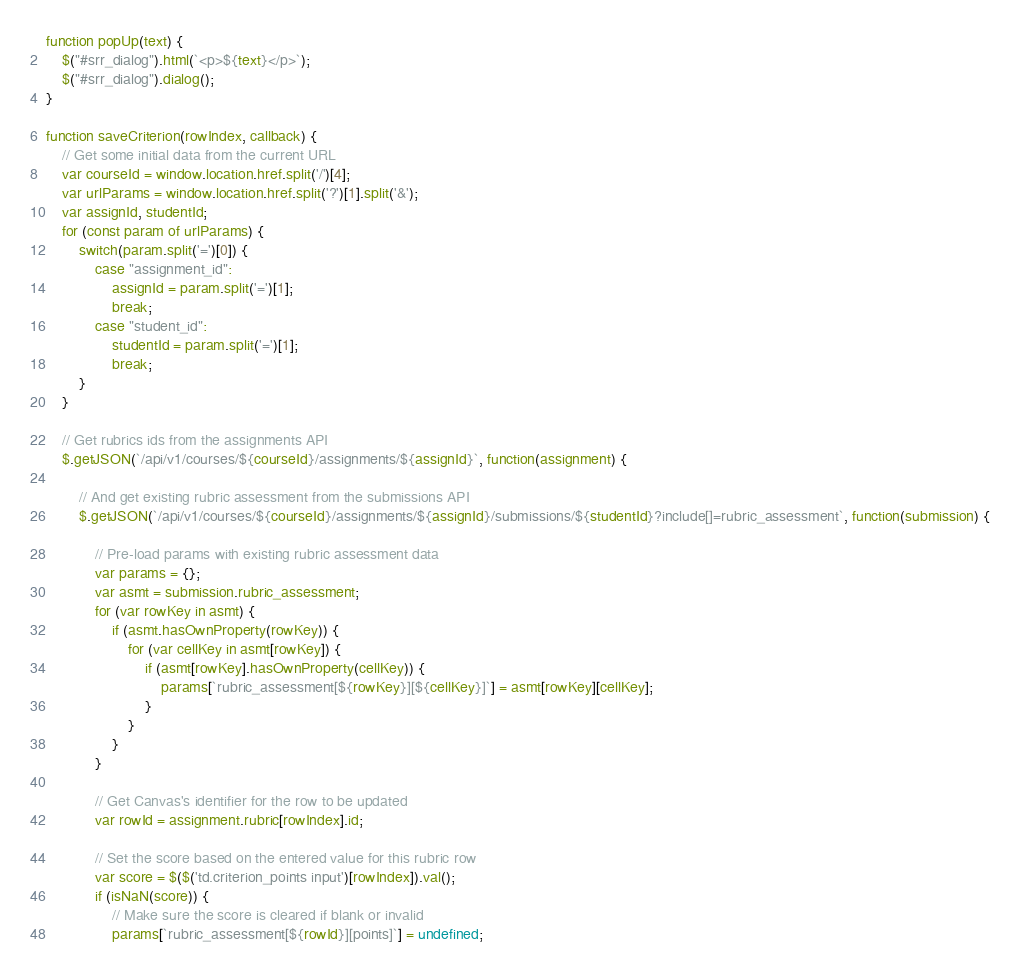<code> <loc_0><loc_0><loc_500><loc_500><_JavaScript_>function popUp(text) {
    $("#srr_dialog").html(`<p>${text}</p>`);
    $("#srr_dialog").dialog();
}

function saveCriterion(rowIndex, callback) {
    // Get some initial data from the current URL
    var courseId = window.location.href.split('/')[4];
    var urlParams = window.location.href.split('?')[1].split('&');
    var assignId, studentId;
    for (const param of urlParams) {
        switch(param.split('=')[0]) {
            case "assignment_id":
                assignId = param.split('=')[1];
                break;
            case "student_id":
                studentId = param.split('=')[1];
                break;
        }
    }

    // Get rubrics ids from the assignments API
    $.getJSON(`/api/v1/courses/${courseId}/assignments/${assignId}`, function(assignment) {

        // And get existing rubric assessment from the submissions API
        $.getJSON(`/api/v1/courses/${courseId}/assignments/${assignId}/submissions/${studentId}?include[]=rubric_assessment`, function(submission) {

            // Pre-load params with existing rubric assessment data
            var params = {};
            var asmt = submission.rubric_assessment;
            for (var rowKey in asmt) {
                if (asmt.hasOwnProperty(rowKey)) {
                    for (var cellKey in asmt[rowKey]) {
                        if (asmt[rowKey].hasOwnProperty(cellKey)) {
                            params[`rubric_assessment[${rowKey}][${cellKey}]`] = asmt[rowKey][cellKey];
                        }
                    }
                }
            }

            // Get Canvas's identifier for the row to be updated
            var rowId = assignment.rubric[rowIndex].id;

            // Set the score based on the entered value for this rubric row
            var score = $($('td.criterion_points input')[rowIndex]).val();
            if (isNaN(score)) {
                // Make sure the score is cleared if blank or invalid
                params[`rubric_assessment[${rowId}][points]`] = undefined;</code> 